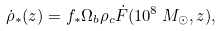<formula> <loc_0><loc_0><loc_500><loc_500>\dot { \rho } _ { * } ( z ) = f _ { * } \Omega _ { b } \rho _ { c } \dot { F } ( 1 0 ^ { 8 } \, M _ { \odot } , z ) ,</formula> 